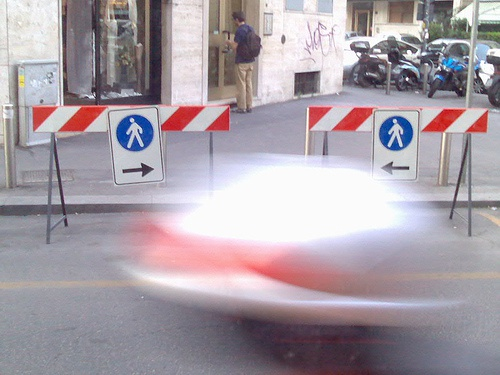Describe the objects in this image and their specific colors. I can see people in ivory, gray, darkgray, and purple tones, motorcycle in ivory, gray, darkgray, purple, and white tones, motorcycle in ivory, gray, darkgray, black, and purple tones, car in ivory, gray, darkgray, white, and lightblue tones, and car in ivory, gray, lightgray, and darkgray tones in this image. 